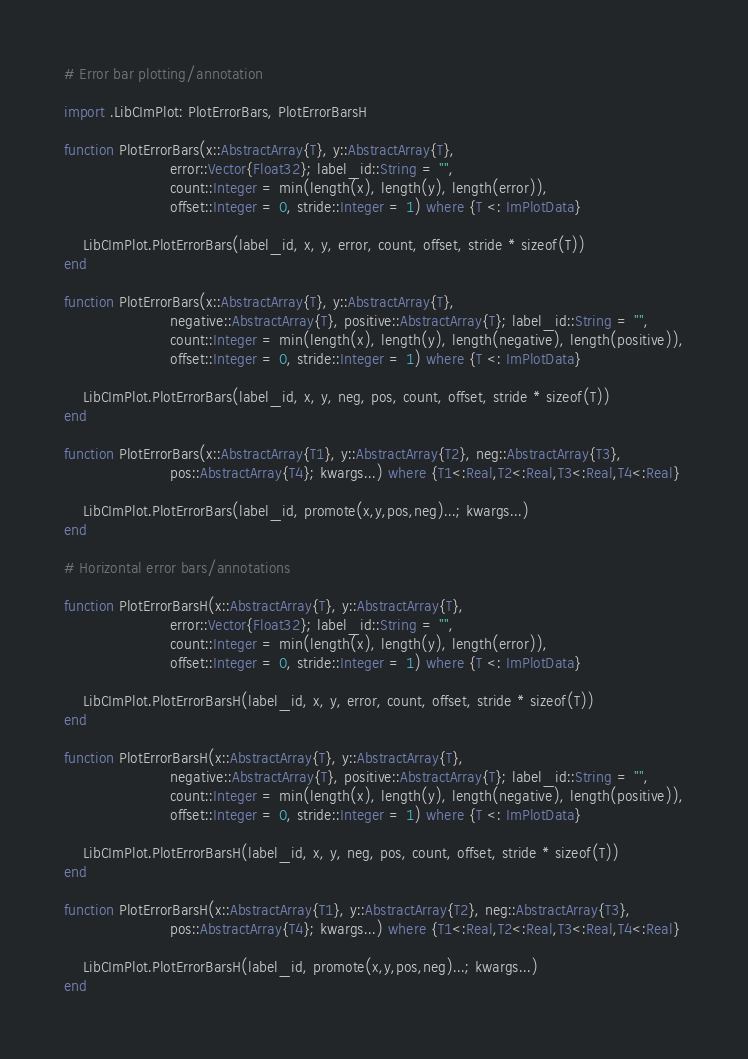Convert code to text. <code><loc_0><loc_0><loc_500><loc_500><_Julia_># Error bar plotting/annotation

import .LibCImPlot: PlotErrorBars, PlotErrorBarsH

function PlotErrorBars(x::AbstractArray{T}, y::AbstractArray{T},
                       error::Vector{Float32}; label_id::String = "",
                       count::Integer = min(length(x), length(y), length(error)),
                       offset::Integer = 0, stride::Integer = 1) where {T <: ImPlotData}

    LibCImPlot.PlotErrorBars(label_id, x, y, error, count, offset, stride * sizeof(T))
end

function PlotErrorBars(x::AbstractArray{T}, y::AbstractArray{T},
                       negative::AbstractArray{T}, positive::AbstractArray{T}; label_id::String = "",
                       count::Integer = min(length(x), length(y), length(negative), length(positive)),
                       offset::Integer = 0, stride::Integer = 1) where {T <: ImPlotData}

    LibCImPlot.PlotErrorBars(label_id, x, y, neg, pos, count, offset, stride * sizeof(T))
end

function PlotErrorBars(x::AbstractArray{T1}, y::AbstractArray{T2}, neg::AbstractArray{T3},
                       pos::AbstractArray{T4}; kwargs...) where {T1<:Real,T2<:Real,T3<:Real,T4<:Real}
    
    LibCImPlot.PlotErrorBars(label_id, promote(x,y,pos,neg)...; kwargs...)
end

# Horizontal error bars/annotations

function PlotErrorBarsH(x::AbstractArray{T}, y::AbstractArray{T},
                       error::Vector{Float32}; label_id::String = "",
                       count::Integer = min(length(x), length(y), length(error)),
                       offset::Integer = 0, stride::Integer = 1) where {T <: ImPlotData}

    LibCImPlot.PlotErrorBarsH(label_id, x, y, error, count, offset, stride * sizeof(T))
end

function PlotErrorBarsH(x::AbstractArray{T}, y::AbstractArray{T},
                       negative::AbstractArray{T}, positive::AbstractArray{T}; label_id::String = "",
                       count::Integer = min(length(x), length(y), length(negative), length(positive)),
                       offset::Integer = 0, stride::Integer = 1) where {T <: ImPlotData}

    LibCImPlot.PlotErrorBarsH(label_id, x, y, neg, pos, count, offset, stride * sizeof(T))
end

function PlotErrorBarsH(x::AbstractArray{T1}, y::AbstractArray{T2}, neg::AbstractArray{T3},
                       pos::AbstractArray{T4}; kwargs...) where {T1<:Real,T2<:Real,T3<:Real,T4<:Real}
    
    LibCImPlot.PlotErrorBarsH(label_id, promote(x,y,pos,neg)...; kwargs...)
end

</code> 